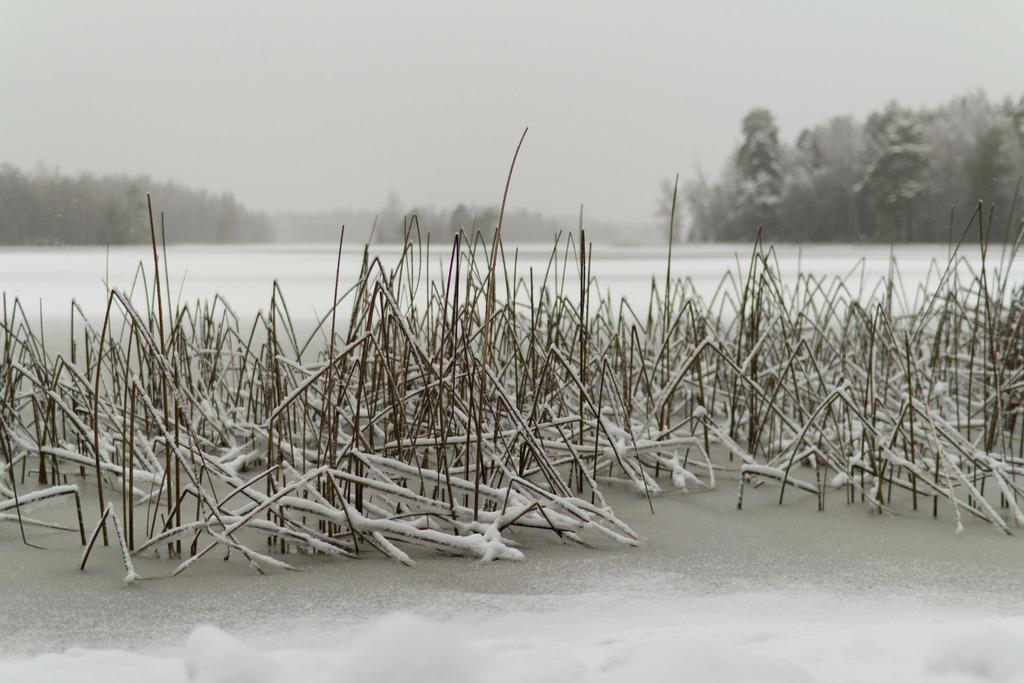What is the primary surface visible in the image? The image shows a snow surface. What can be seen on the snow surface? Dried grass is present on the snow surface. What type of vegetation is visible in the background of the image? There are plants and trees visible in the background of the image. What atmospheric condition is present in the background of the image? Fog is present in the background of the image. What part of the natural environment is visible in the background of the image? The sky is visible in the background of the image. What type of acoustics can be heard in the image? There is no sound present in the image, so it is not possible to determine the type of acoustics. What is the reaction of the dad in the image? There is no dad present in the image, so it is not possible to determine his reaction. 